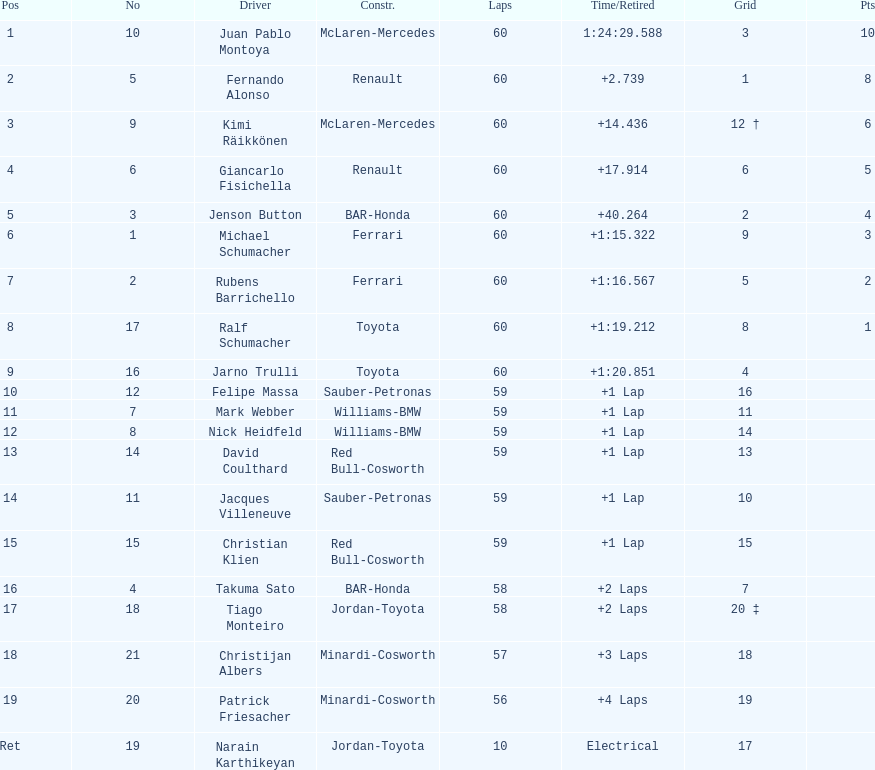How many drivers from germany? 3. 